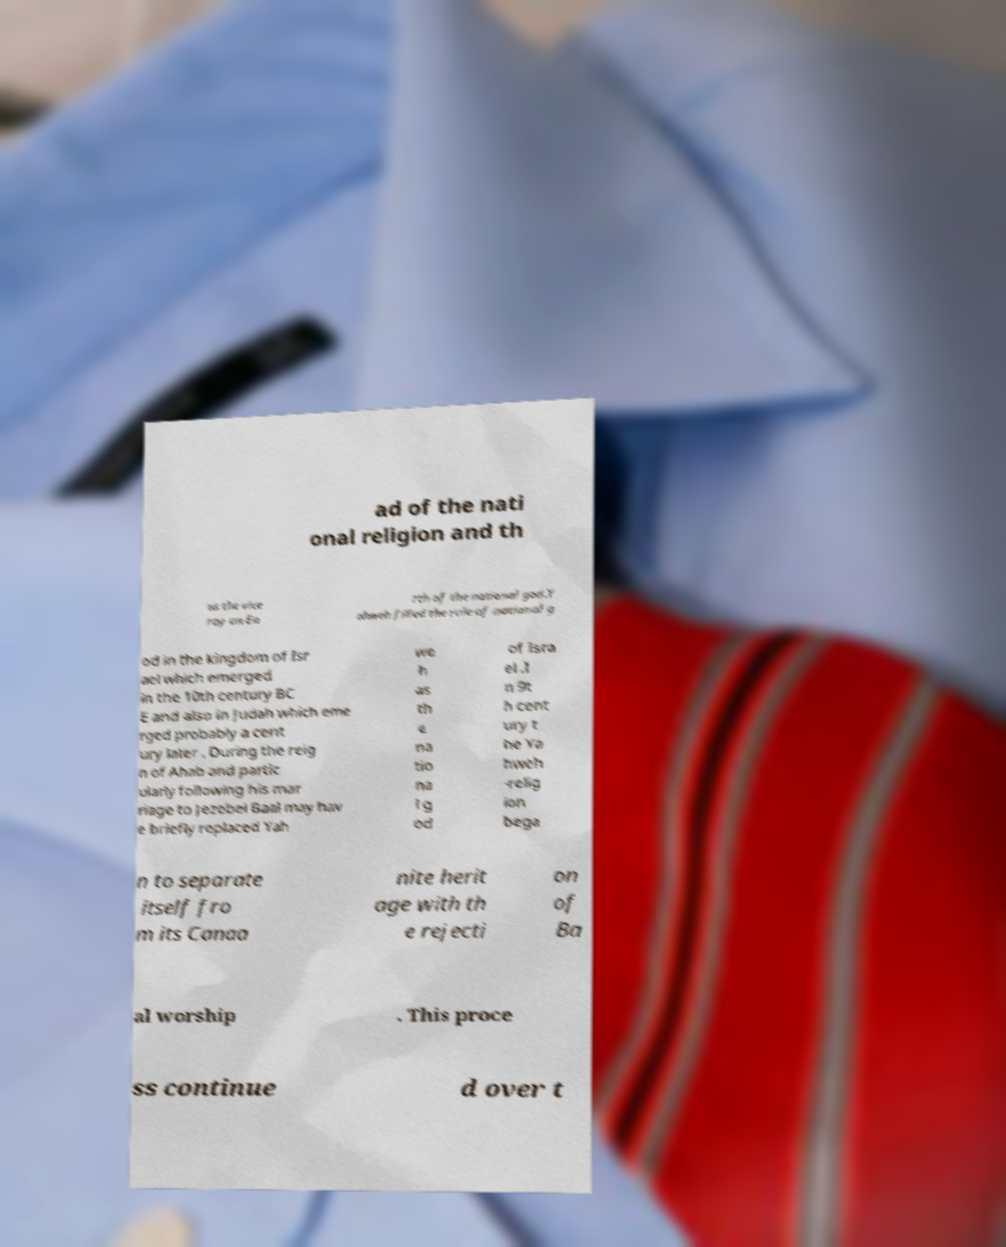Could you assist in decoding the text presented in this image and type it out clearly? ad of the nati onal religion and th us the vice roy on Ea rth of the national god.Y ahweh filled the role of national g od in the kingdom of Isr ael which emerged in the 10th century BC E and also in Judah which eme rged probably a cent ury later . During the reig n of Ahab and partic ularly following his mar riage to Jezebel Baal may hav e briefly replaced Yah we h as th e na tio na l g od of Isra el .I n 9t h cent ury t he Ya hweh -relig ion bega n to separate itself fro m its Canaa nite herit age with th e rejecti on of Ba al worship . This proce ss continue d over t 